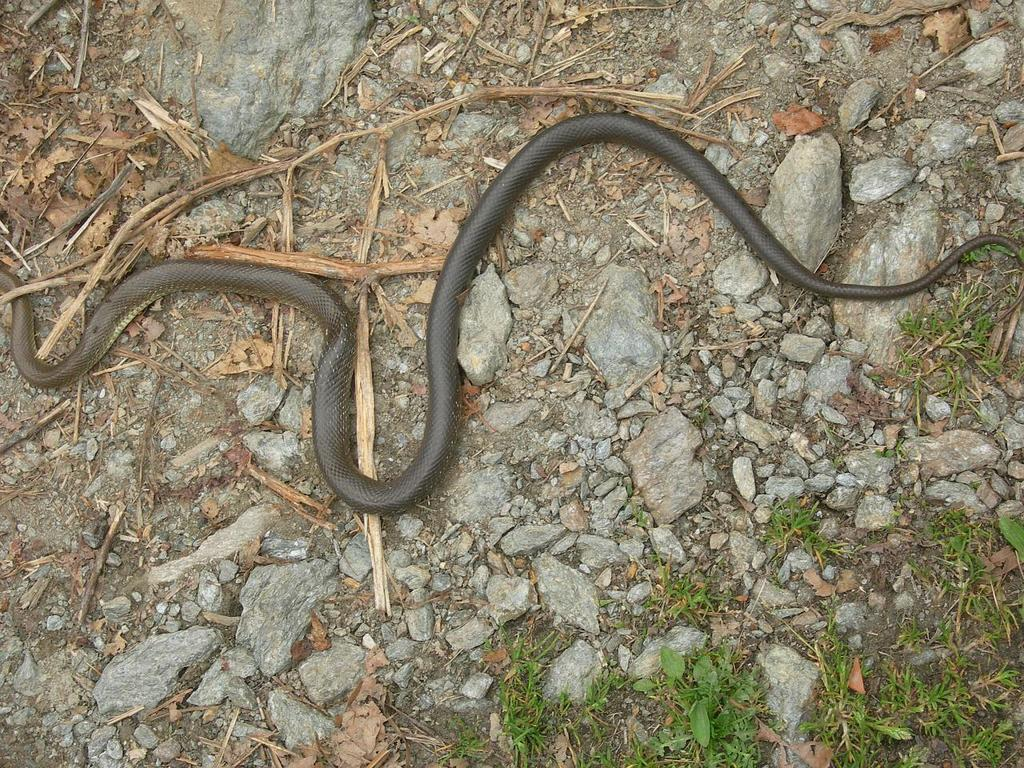What animal is present in the image? There is a snake in the image. Where is the snake located? The snake is on the ground. What is the color of the snake? The snake is black in color. What other objects can be seen in the image? There are wooden sticks, stones, and grass in the image. What type of insurance policy is the snake considering in the image? There is no mention of insurance in the image, as it features a snake on the ground with wooden sticks, stones, and grass. 